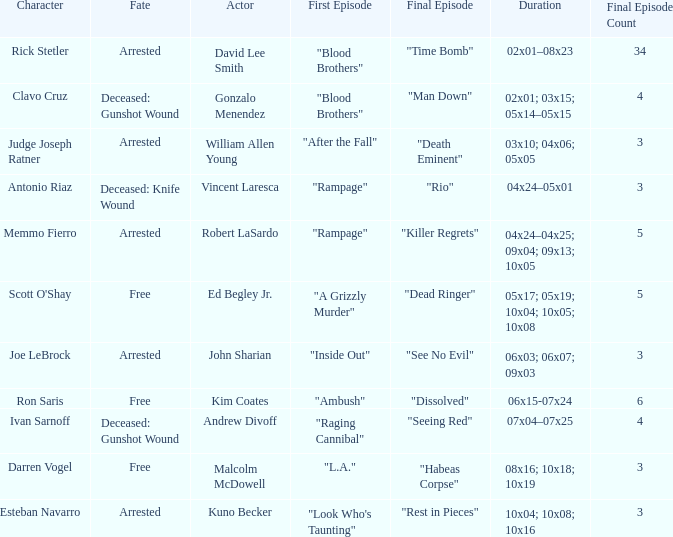What's the first epbeingode with final epbeingode being "rio" "Rampage". 